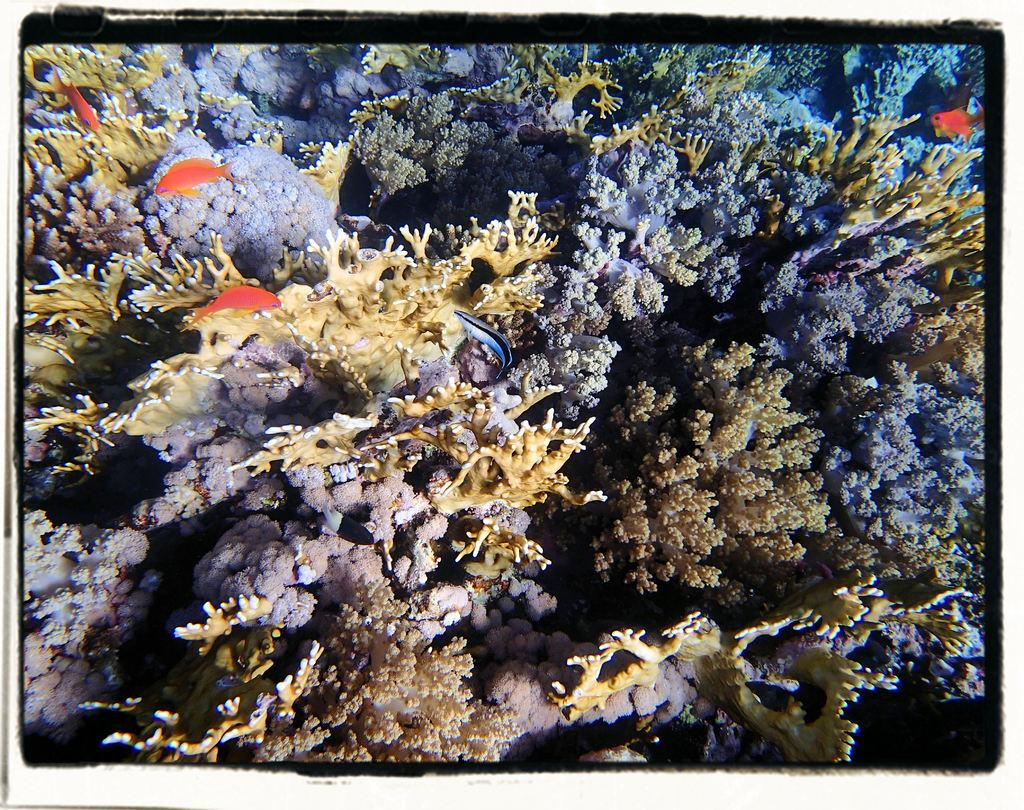What type of environment is shown in the image? The image depicts an underwater environment. What kind of marine life can be seen in the image? There are fishes visible in the image. What geological feature is present in the underwater environment? The underwater coral reef is present in the image. How does the diver grip the coral reef in the image? There is no diver present in the image, so it is not possible to determine how a diver might grip the coral reef. 